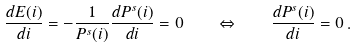Convert formula to latex. <formula><loc_0><loc_0><loc_500><loc_500>\frac { d E ( i ) } { d i } = - \frac { 1 } { P ^ { s } ( i ) } \frac { d P ^ { s } ( i ) } { d i } = 0 \quad \Leftrightarrow \quad \frac { d P ^ { s } ( i ) } { d i } = 0 \, .</formula> 